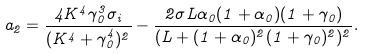<formula> <loc_0><loc_0><loc_500><loc_500>a _ { 2 } = \frac { 4 K ^ { 4 } \gamma _ { 0 } ^ { 3 } \sigma _ { i } } { ( K ^ { 4 } + \gamma _ { 0 } ^ { 4 } ) ^ { 2 } } - \frac { 2 \sigma L \alpha _ { 0 } ( 1 + \alpha _ { 0 } ) ( 1 + \gamma _ { 0 } ) } { ( L + ( 1 + \alpha _ { 0 } ) ^ { 2 } ( 1 + \gamma _ { 0 } ) ^ { 2 } ) ^ { 2 } } .</formula> 